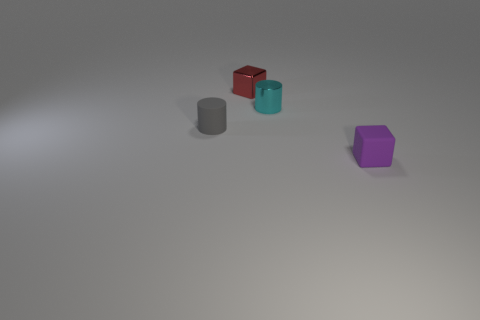Add 2 purple rubber blocks. How many objects exist? 6 Subtract all purple blocks. Subtract all red cylinders. How many blocks are left? 1 Subtract all yellow cylinders. How many red blocks are left? 1 Subtract all tiny gray objects. Subtract all small metallic things. How many objects are left? 1 Add 4 cyan metallic objects. How many cyan metallic objects are left? 5 Add 3 tiny matte cylinders. How many tiny matte cylinders exist? 4 Subtract 1 red cubes. How many objects are left? 3 Subtract 1 cylinders. How many cylinders are left? 1 